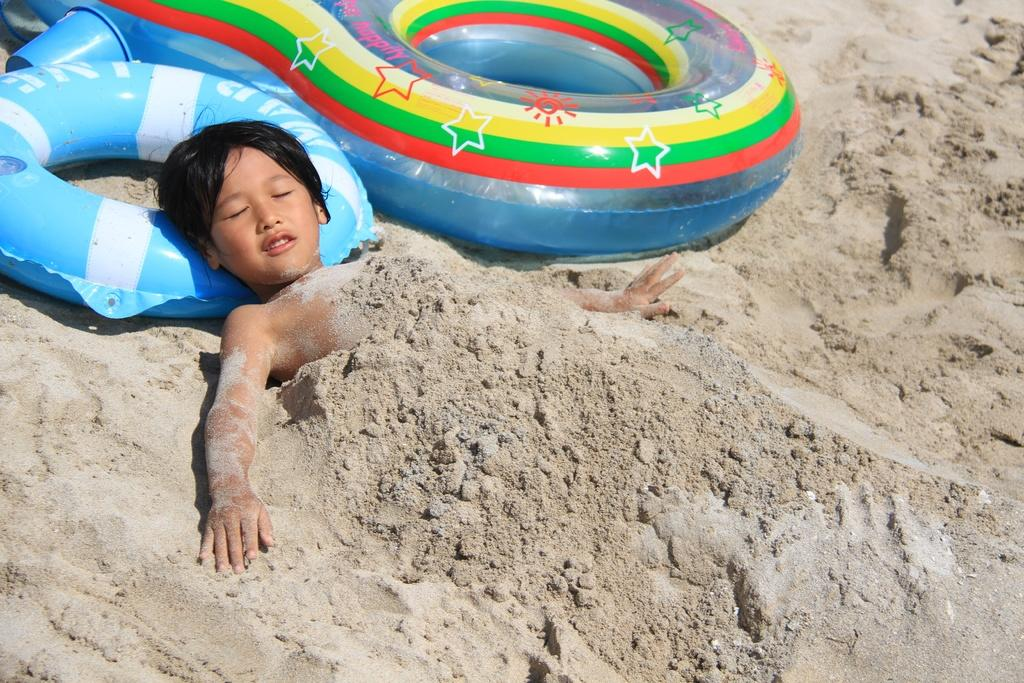What objects can be seen in the image? There are tubes in the image. What is the child doing in the image? The child is lying on the sand. What is the child using to support their head? The child's head is resting on a tube. What type of surface is the child lying on? The child is lying on sand. What color is the scarf wrapped around the child's neck in the image? There is no scarf present in the image. What position is the bear in while lying next to the child on the sand? There is no bear present in the image. 